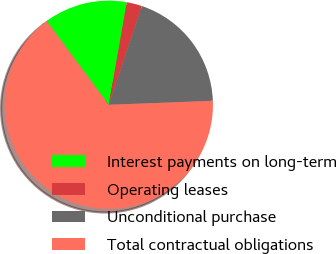Convert chart to OTSL. <chart><loc_0><loc_0><loc_500><loc_500><pie_chart><fcel>Interest payments on long-term<fcel>Operating leases<fcel>Unconditional purchase<fcel>Total contractual obligations<nl><fcel>12.92%<fcel>2.39%<fcel>19.23%<fcel>65.46%<nl></chart> 